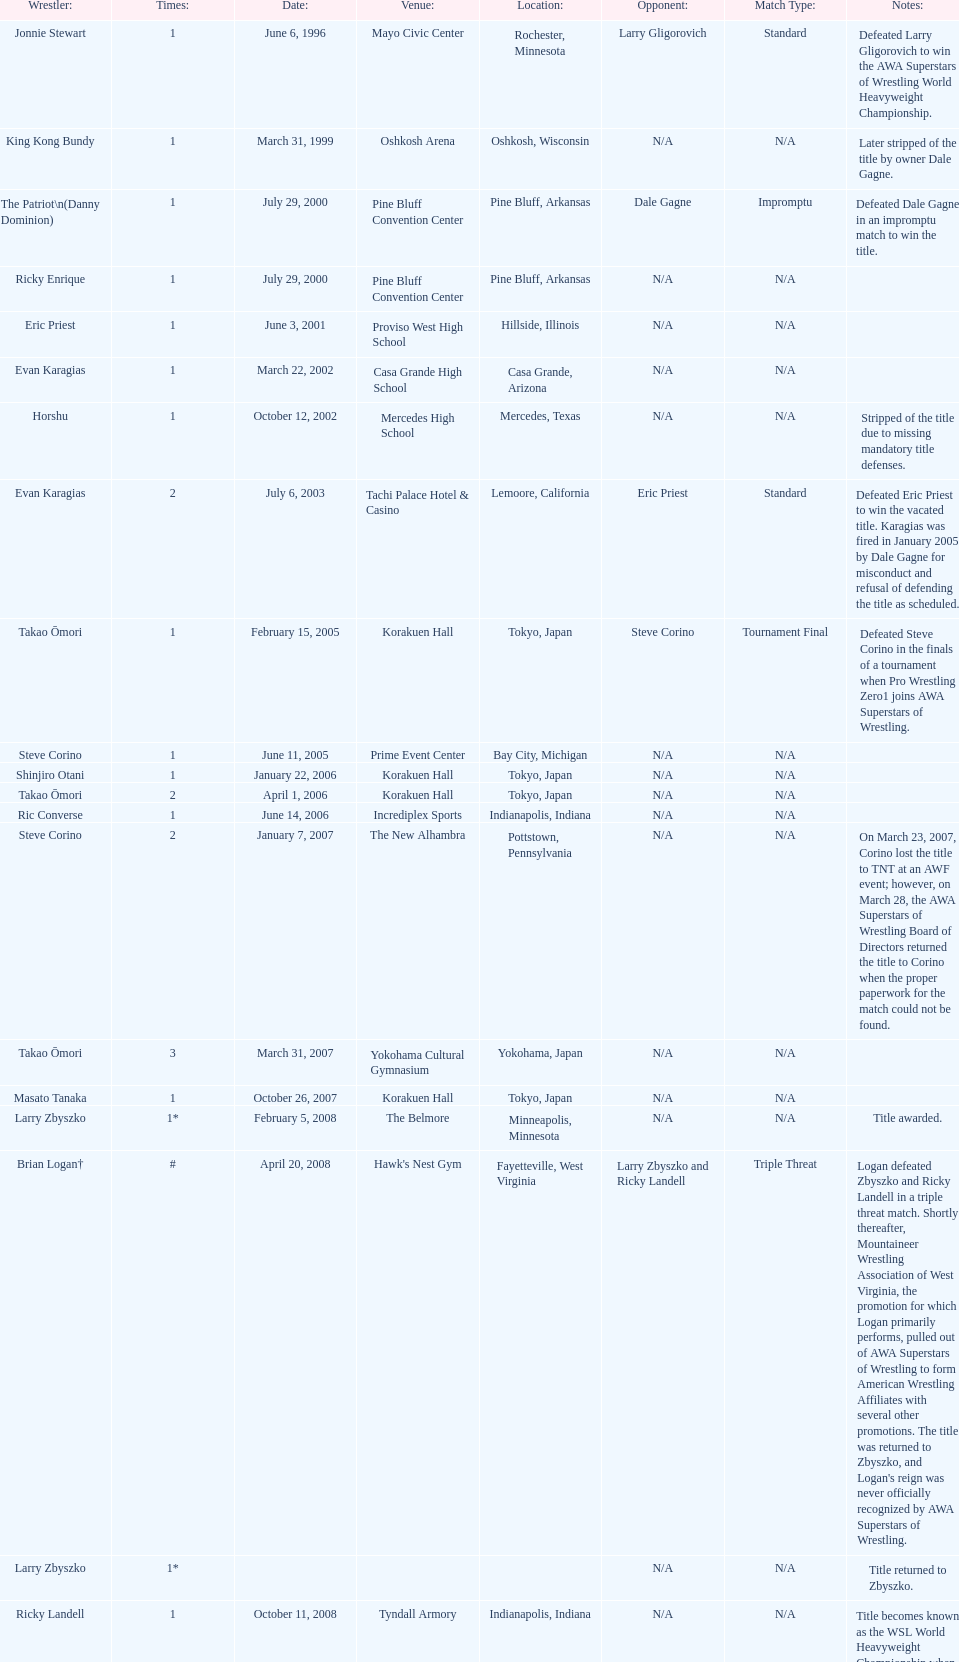When did steve corino win his first wsl title? June 11, 2005. 